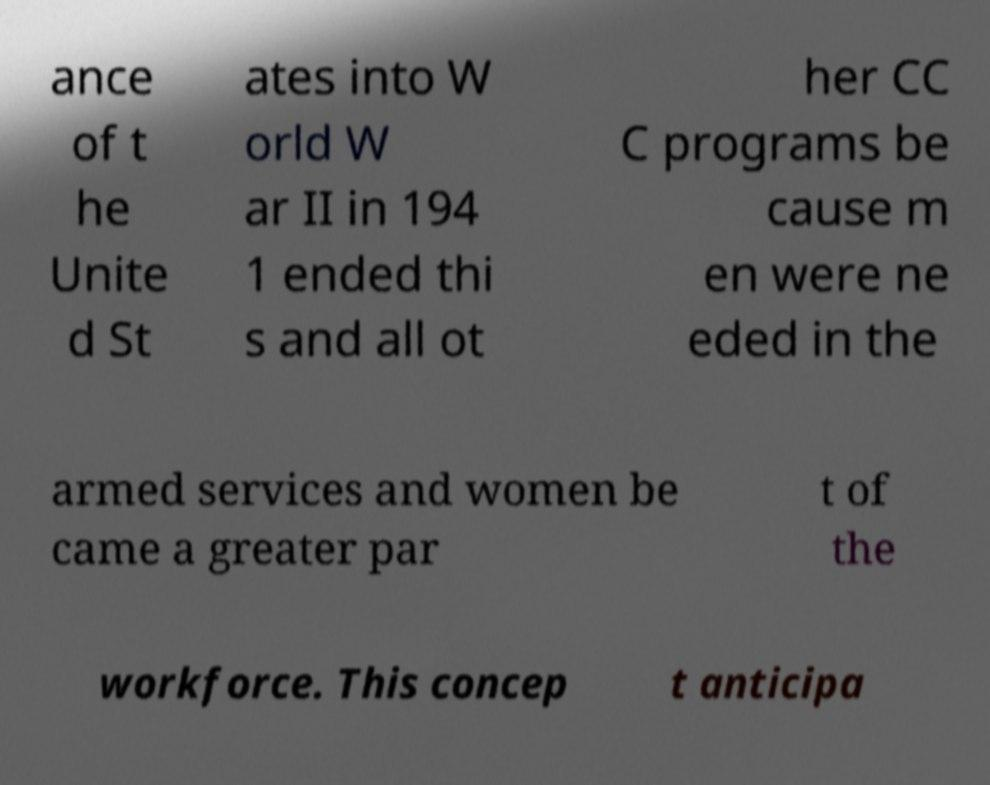For documentation purposes, I need the text within this image transcribed. Could you provide that? ance of t he Unite d St ates into W orld W ar II in 194 1 ended thi s and all ot her CC C programs be cause m en were ne eded in the armed services and women be came a greater par t of the workforce. This concep t anticipa 